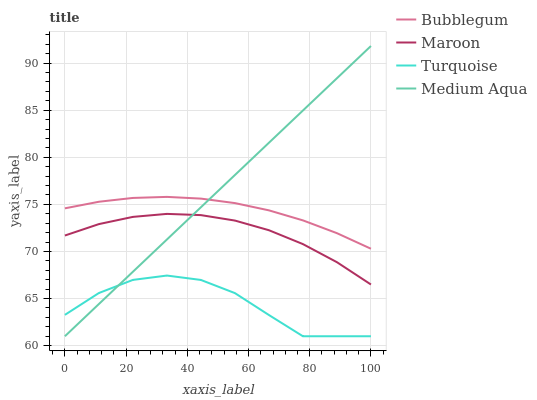Does Turquoise have the minimum area under the curve?
Answer yes or no. Yes. Does Medium Aqua have the maximum area under the curve?
Answer yes or no. Yes. Does Maroon have the minimum area under the curve?
Answer yes or no. No. Does Maroon have the maximum area under the curve?
Answer yes or no. No. Is Medium Aqua the smoothest?
Answer yes or no. Yes. Is Turquoise the roughest?
Answer yes or no. Yes. Is Maroon the smoothest?
Answer yes or no. No. Is Maroon the roughest?
Answer yes or no. No. Does Turquoise have the lowest value?
Answer yes or no. Yes. Does Maroon have the lowest value?
Answer yes or no. No. Does Medium Aqua have the highest value?
Answer yes or no. Yes. Does Maroon have the highest value?
Answer yes or no. No. Is Turquoise less than Bubblegum?
Answer yes or no. Yes. Is Bubblegum greater than Turquoise?
Answer yes or no. Yes. Does Maroon intersect Medium Aqua?
Answer yes or no. Yes. Is Maroon less than Medium Aqua?
Answer yes or no. No. Is Maroon greater than Medium Aqua?
Answer yes or no. No. Does Turquoise intersect Bubblegum?
Answer yes or no. No. 